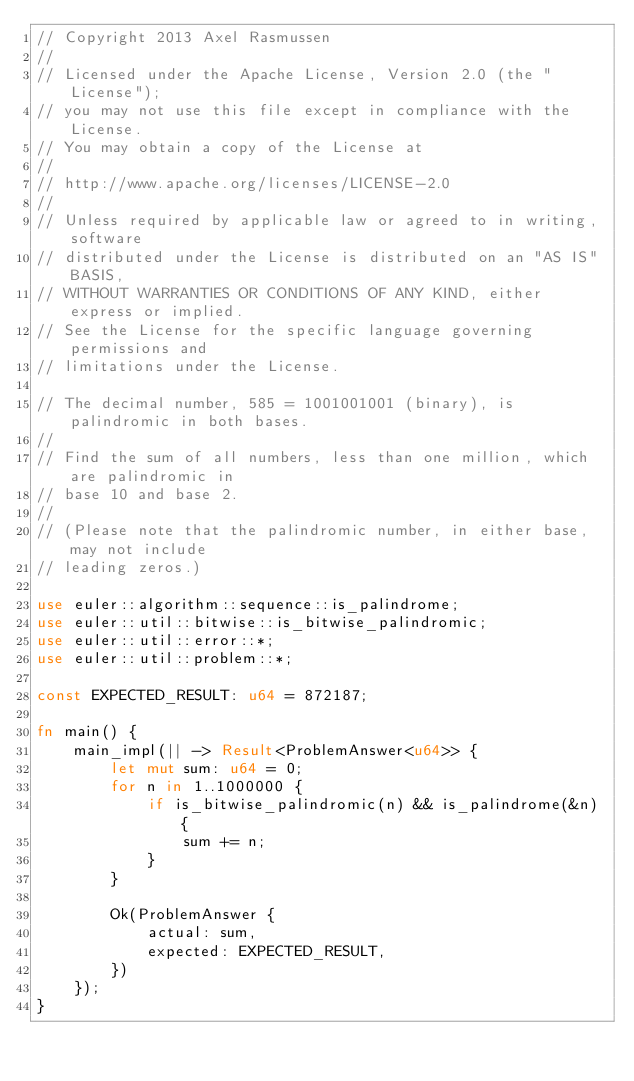Convert code to text. <code><loc_0><loc_0><loc_500><loc_500><_Rust_>// Copyright 2013 Axel Rasmussen
//
// Licensed under the Apache License, Version 2.0 (the "License");
// you may not use this file except in compliance with the License.
// You may obtain a copy of the License at
//
// http://www.apache.org/licenses/LICENSE-2.0
//
// Unless required by applicable law or agreed to in writing, software
// distributed under the License is distributed on an "AS IS" BASIS,
// WITHOUT WARRANTIES OR CONDITIONS OF ANY KIND, either express or implied.
// See the License for the specific language governing permissions and
// limitations under the License.

// The decimal number, 585 = 1001001001 (binary), is palindromic in both bases.
//
// Find the sum of all numbers, less than one million, which are palindromic in
// base 10 and base 2.
//
// (Please note that the palindromic number, in either base, may not include
// leading zeros.)

use euler::algorithm::sequence::is_palindrome;
use euler::util::bitwise::is_bitwise_palindromic;
use euler::util::error::*;
use euler::util::problem::*;

const EXPECTED_RESULT: u64 = 872187;

fn main() {
    main_impl(|| -> Result<ProblemAnswer<u64>> {
        let mut sum: u64 = 0;
        for n in 1..1000000 {
            if is_bitwise_palindromic(n) && is_palindrome(&n) {
                sum += n;
            }
        }

        Ok(ProblemAnswer {
            actual: sum,
            expected: EXPECTED_RESULT,
        })
    });
}
</code> 